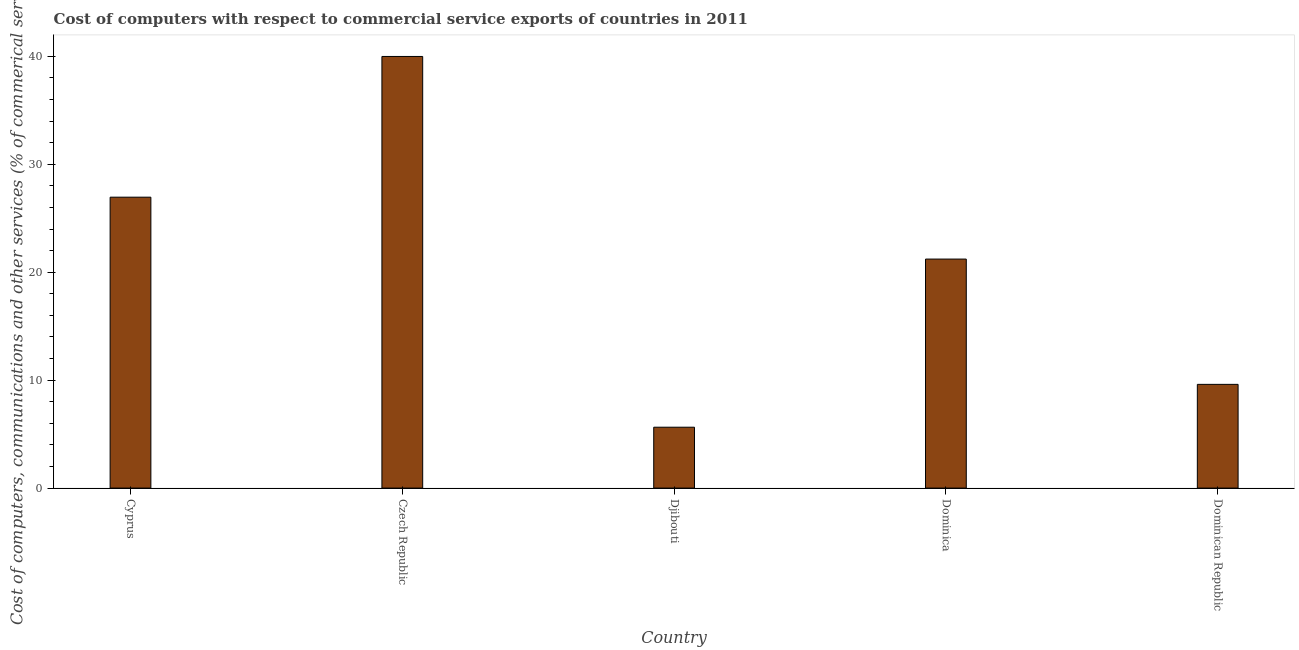Does the graph contain any zero values?
Your answer should be compact. No. Does the graph contain grids?
Keep it short and to the point. No. What is the title of the graph?
Keep it short and to the point. Cost of computers with respect to commercial service exports of countries in 2011. What is the label or title of the Y-axis?
Keep it short and to the point. Cost of computers, communications and other services (% of commerical service exports). What is the  computer and other services in Czech Republic?
Keep it short and to the point. 39.99. Across all countries, what is the maximum cost of communications?
Keep it short and to the point. 39.99. Across all countries, what is the minimum  computer and other services?
Offer a very short reply. 5.64. In which country was the  computer and other services maximum?
Offer a very short reply. Czech Republic. In which country was the cost of communications minimum?
Your response must be concise. Djibouti. What is the sum of the  computer and other services?
Give a very brief answer. 103.42. What is the difference between the cost of communications in Dominica and Dominican Republic?
Ensure brevity in your answer.  11.61. What is the average cost of communications per country?
Provide a short and direct response. 20.68. What is the median cost of communications?
Ensure brevity in your answer.  21.22. In how many countries, is the cost of communications greater than 16 %?
Keep it short and to the point. 3. What is the ratio of the  computer and other services in Czech Republic to that in Dominican Republic?
Give a very brief answer. 4.16. Is the difference between the  computer and other services in Cyprus and Dominica greater than the difference between any two countries?
Provide a short and direct response. No. What is the difference between the highest and the second highest  computer and other services?
Offer a very short reply. 13.04. Is the sum of the  computer and other services in Czech Republic and Djibouti greater than the maximum  computer and other services across all countries?
Keep it short and to the point. Yes. What is the difference between the highest and the lowest cost of communications?
Your answer should be very brief. 34.35. How many bars are there?
Provide a short and direct response. 5. Are all the bars in the graph horizontal?
Make the answer very short. No. What is the difference between two consecutive major ticks on the Y-axis?
Your answer should be very brief. 10. Are the values on the major ticks of Y-axis written in scientific E-notation?
Keep it short and to the point. No. What is the Cost of computers, communications and other services (% of commerical service exports) in Cyprus?
Your response must be concise. 26.95. What is the Cost of computers, communications and other services (% of commerical service exports) in Czech Republic?
Your answer should be compact. 39.99. What is the Cost of computers, communications and other services (% of commerical service exports) in Djibouti?
Give a very brief answer. 5.64. What is the Cost of computers, communications and other services (% of commerical service exports) of Dominica?
Ensure brevity in your answer.  21.22. What is the Cost of computers, communications and other services (% of commerical service exports) in Dominican Republic?
Give a very brief answer. 9.61. What is the difference between the Cost of computers, communications and other services (% of commerical service exports) in Cyprus and Czech Republic?
Your answer should be compact. -13.04. What is the difference between the Cost of computers, communications and other services (% of commerical service exports) in Cyprus and Djibouti?
Give a very brief answer. 21.31. What is the difference between the Cost of computers, communications and other services (% of commerical service exports) in Cyprus and Dominica?
Make the answer very short. 5.74. What is the difference between the Cost of computers, communications and other services (% of commerical service exports) in Cyprus and Dominican Republic?
Make the answer very short. 17.34. What is the difference between the Cost of computers, communications and other services (% of commerical service exports) in Czech Republic and Djibouti?
Ensure brevity in your answer.  34.35. What is the difference between the Cost of computers, communications and other services (% of commerical service exports) in Czech Republic and Dominica?
Give a very brief answer. 18.77. What is the difference between the Cost of computers, communications and other services (% of commerical service exports) in Czech Republic and Dominican Republic?
Ensure brevity in your answer.  30.38. What is the difference between the Cost of computers, communications and other services (% of commerical service exports) in Djibouti and Dominica?
Provide a succinct answer. -15.58. What is the difference between the Cost of computers, communications and other services (% of commerical service exports) in Djibouti and Dominican Republic?
Your response must be concise. -3.97. What is the difference between the Cost of computers, communications and other services (% of commerical service exports) in Dominica and Dominican Republic?
Make the answer very short. 11.61. What is the ratio of the Cost of computers, communications and other services (% of commerical service exports) in Cyprus to that in Czech Republic?
Ensure brevity in your answer.  0.67. What is the ratio of the Cost of computers, communications and other services (% of commerical service exports) in Cyprus to that in Djibouti?
Offer a very short reply. 4.78. What is the ratio of the Cost of computers, communications and other services (% of commerical service exports) in Cyprus to that in Dominica?
Offer a very short reply. 1.27. What is the ratio of the Cost of computers, communications and other services (% of commerical service exports) in Cyprus to that in Dominican Republic?
Your answer should be compact. 2.81. What is the ratio of the Cost of computers, communications and other services (% of commerical service exports) in Czech Republic to that in Djibouti?
Your response must be concise. 7.09. What is the ratio of the Cost of computers, communications and other services (% of commerical service exports) in Czech Republic to that in Dominica?
Your answer should be very brief. 1.89. What is the ratio of the Cost of computers, communications and other services (% of commerical service exports) in Czech Republic to that in Dominican Republic?
Your answer should be compact. 4.16. What is the ratio of the Cost of computers, communications and other services (% of commerical service exports) in Djibouti to that in Dominica?
Ensure brevity in your answer.  0.27. What is the ratio of the Cost of computers, communications and other services (% of commerical service exports) in Djibouti to that in Dominican Republic?
Make the answer very short. 0.59. What is the ratio of the Cost of computers, communications and other services (% of commerical service exports) in Dominica to that in Dominican Republic?
Provide a succinct answer. 2.21. 